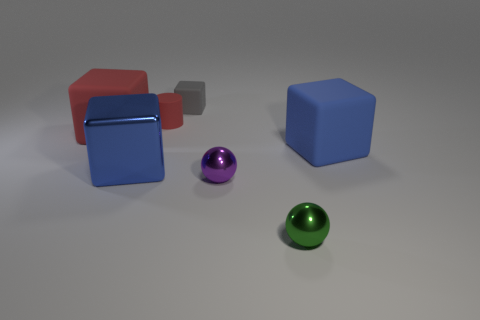There is a object that is the same color as the rubber cylinder; what shape is it?
Keep it short and to the point. Cube. What number of other things are there of the same shape as the gray object?
Make the answer very short. 3. There is another big cube that is the same color as the big shiny block; what is its material?
Your answer should be compact. Rubber. Are any small purple shiny cubes visible?
Give a very brief answer. No. What is the material of the other object that is the same shape as the purple thing?
Keep it short and to the point. Metal. Are there any tiny gray matte things left of the large red rubber object?
Offer a very short reply. No. Is the red thing right of the large metallic thing made of the same material as the gray object?
Provide a succinct answer. Yes. Are there any balls of the same color as the cylinder?
Your answer should be very brief. No. What is the shape of the big metal thing?
Provide a short and direct response. Cube. The tiny matte object that is behind the red thing to the right of the red block is what color?
Give a very brief answer. Gray. 